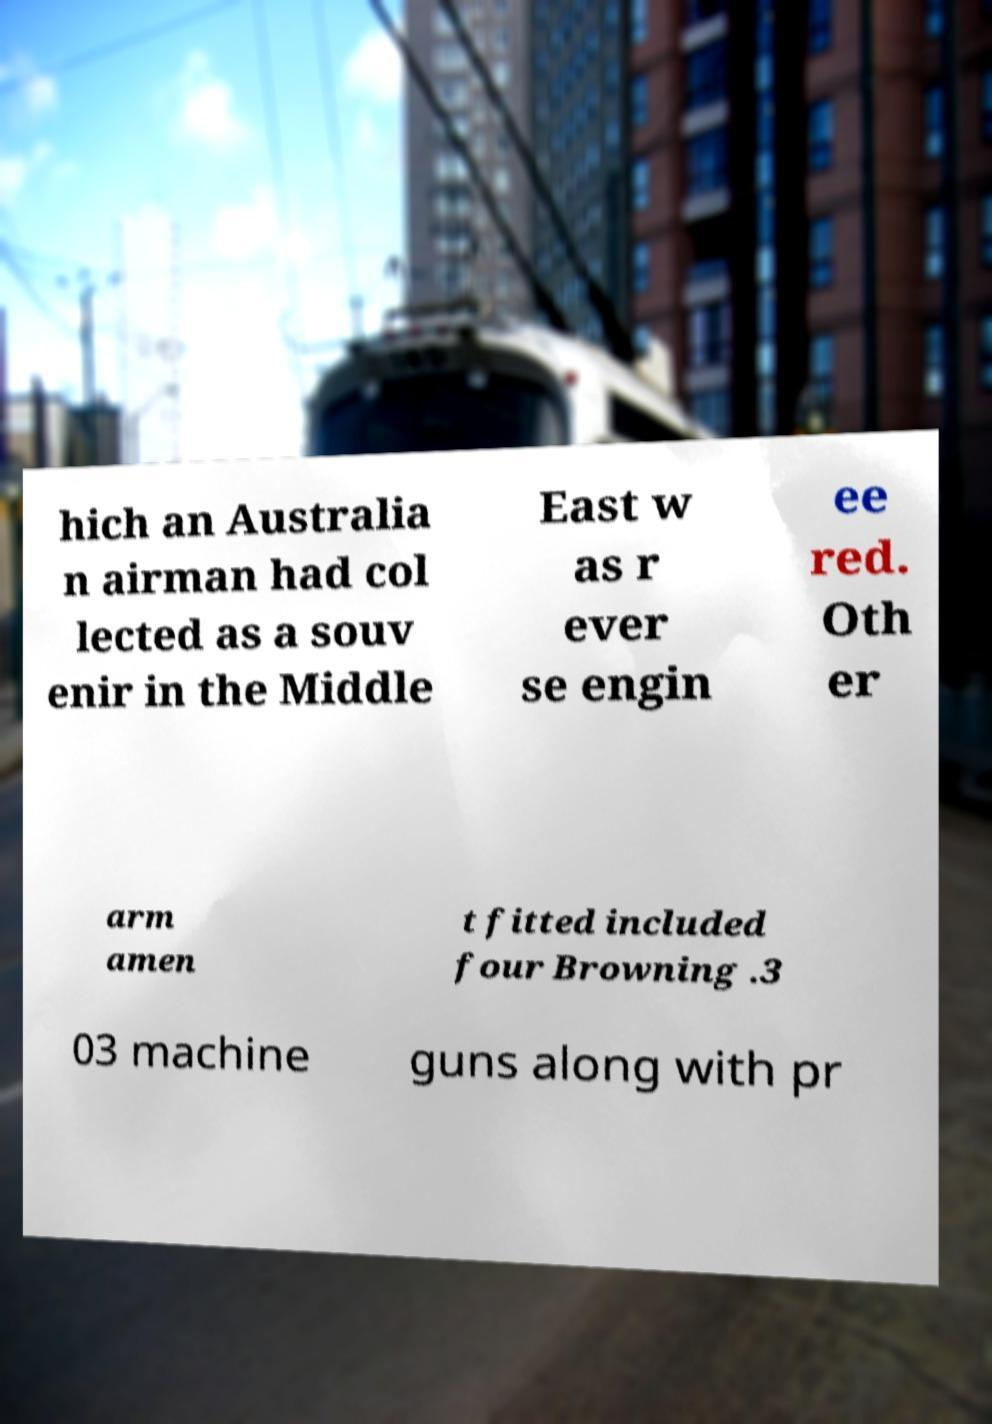Could you assist in decoding the text presented in this image and type it out clearly? hich an Australia n airman had col lected as a souv enir in the Middle East w as r ever se engin ee red. Oth er arm amen t fitted included four Browning .3 03 machine guns along with pr 